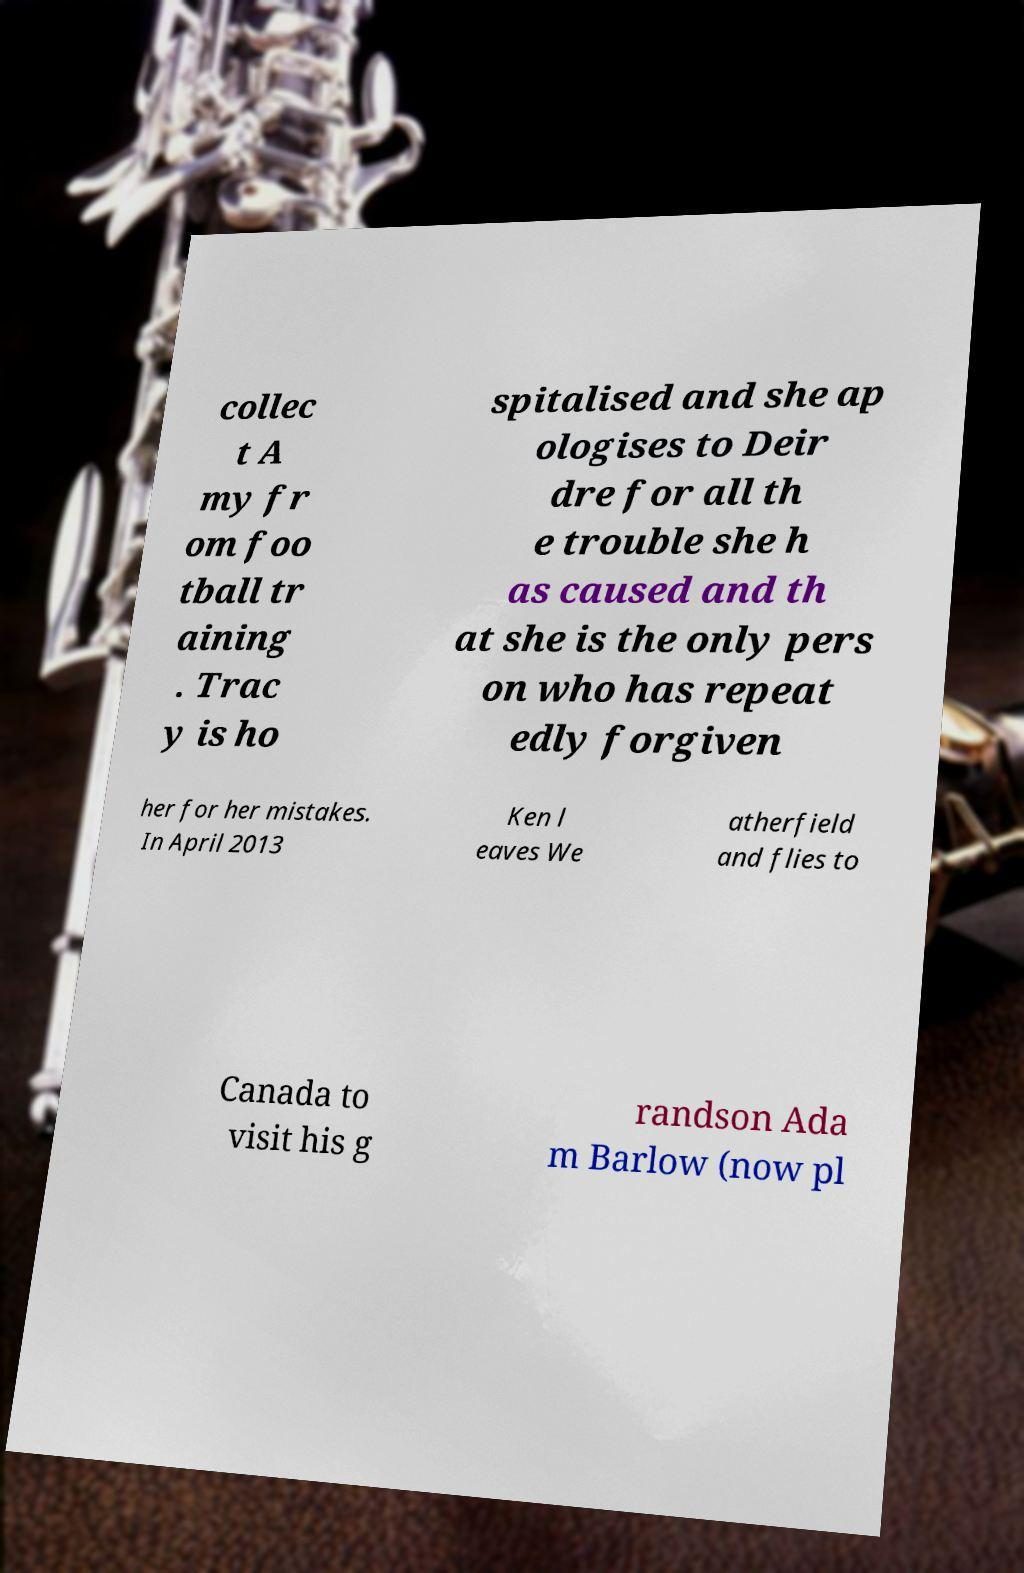Could you assist in decoding the text presented in this image and type it out clearly? collec t A my fr om foo tball tr aining . Trac y is ho spitalised and she ap ologises to Deir dre for all th e trouble she h as caused and th at she is the only pers on who has repeat edly forgiven her for her mistakes. In April 2013 Ken l eaves We atherfield and flies to Canada to visit his g randson Ada m Barlow (now pl 